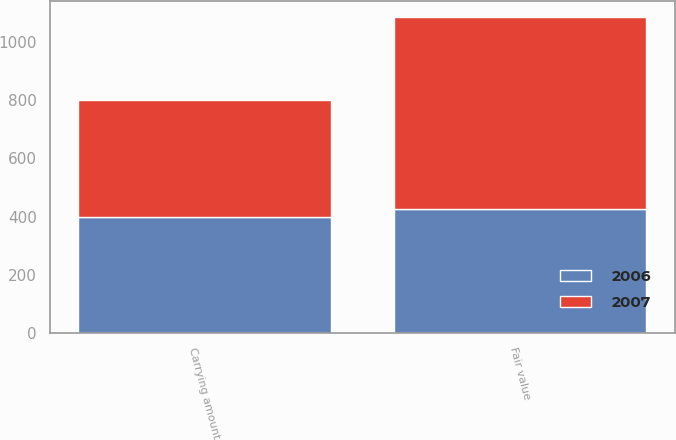Convert chart to OTSL. <chart><loc_0><loc_0><loc_500><loc_500><stacked_bar_chart><ecel><fcel>Carrying amount<fcel>Fair value<nl><fcel>2007<fcel>399.5<fcel>659.2<nl><fcel>2006<fcel>399.9<fcel>427.9<nl></chart> 